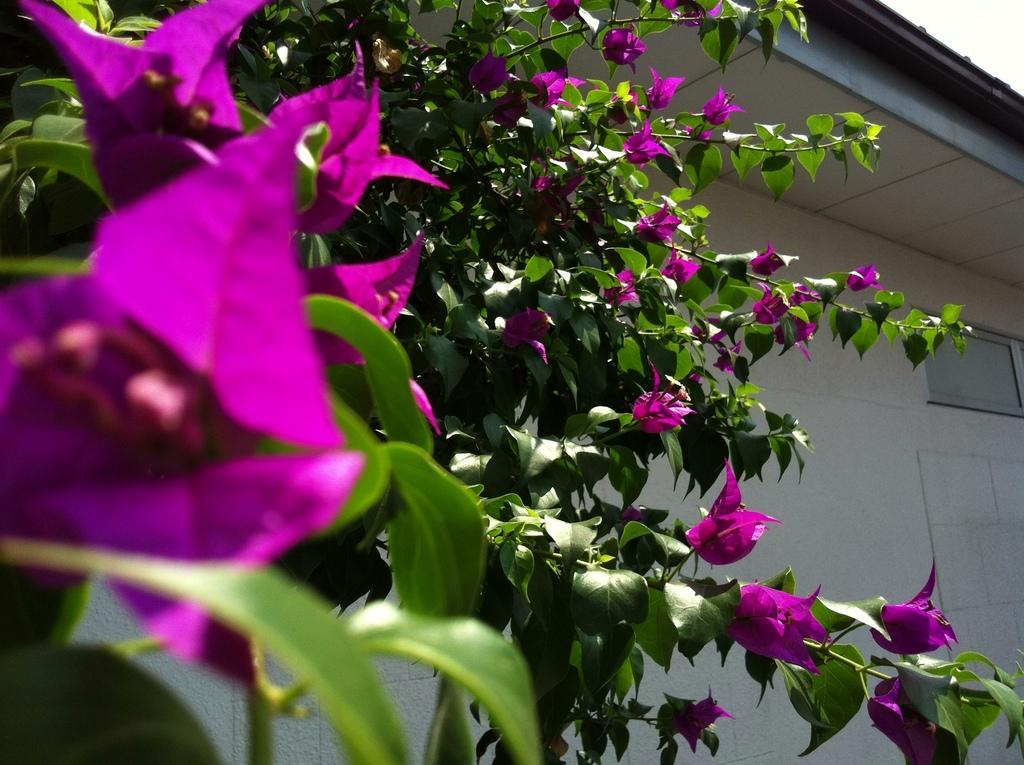Please provide a concise description of this image. In the foreground of this image, flowers to a tree. In the background, there is a wall of a building. At the top, there is the sky. 